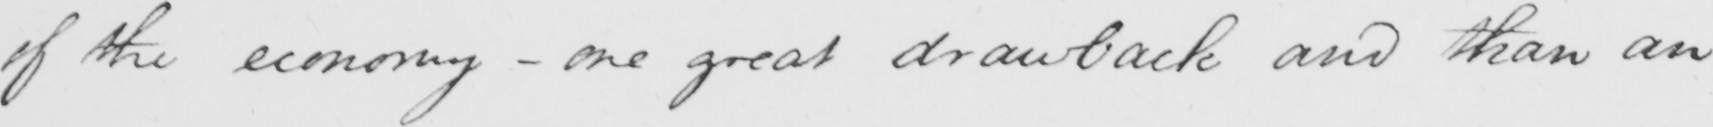Can you read and transcribe this handwriting? of the economy  _  one great drawback and than an 